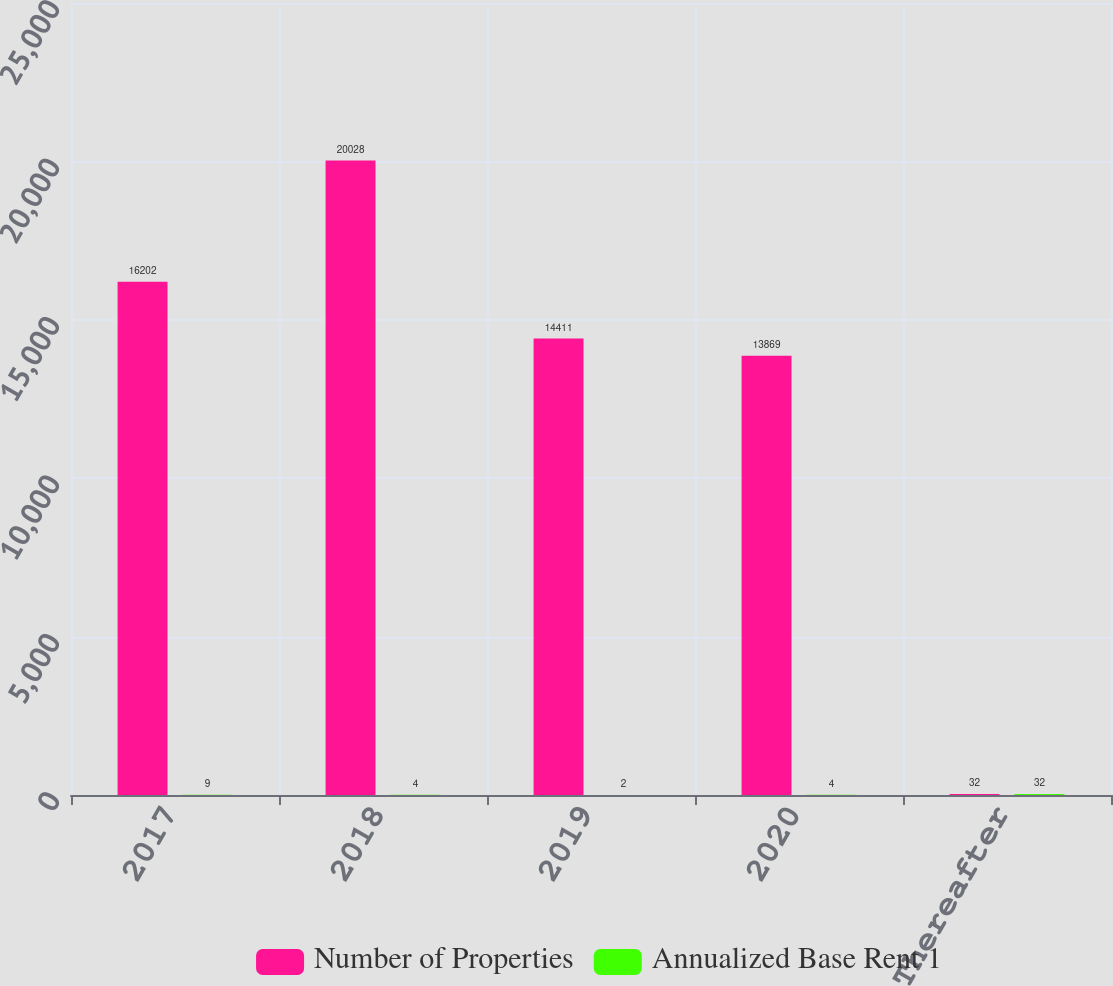<chart> <loc_0><loc_0><loc_500><loc_500><stacked_bar_chart><ecel><fcel>2017<fcel>2018<fcel>2019<fcel>2020<fcel>Thereafter<nl><fcel>Number of Properties<fcel>16202<fcel>20028<fcel>14411<fcel>13869<fcel>32<nl><fcel>Annualized Base Rent 1<fcel>9<fcel>4<fcel>2<fcel>4<fcel>32<nl></chart> 